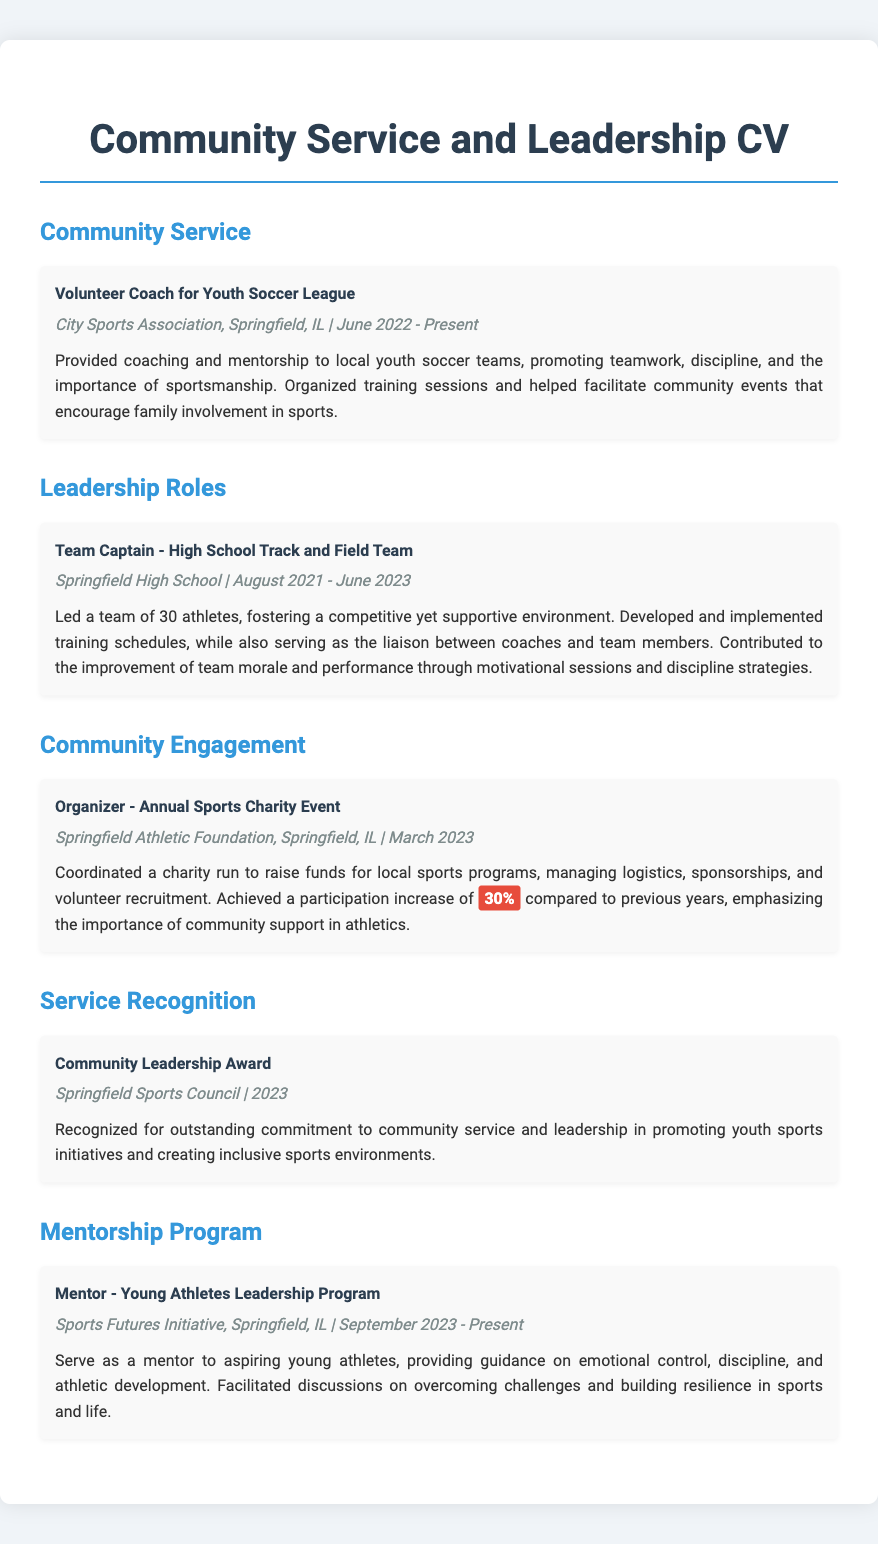What is the title of the community service role? The document specifies the community service role as "Volunteer Coach for Youth Soccer League."
Answer: Volunteer Coach for Youth Soccer League In which year did the Team Captain role begin? The role of Team Captain started in August 2021, as mentioned in the entry details.
Answer: August 2021 What organization recognized the Community Leadership Award? The Community Leadership Award was recognized by the Springfield Sports Council.
Answer: Springfield Sports Council What was the percentage increase in participation for the Annual Sports Charity Event? The document states a participation increase of 30% compared to previous years.
Answer: 30% Which program do you serve as a mentor for? The document mentions the Young Athletes Leadership Program in the mentorship section.
Answer: Young Athletes Leadership Program What was the duration of the Volunteer Coach position? The role of Volunteer Coach has been active from June 2022 to the present date, indicating continuous involvement.
Answer: June 2022 - Present What was the main focus of your mentorship in the Young Athletes Leadership Program? The focus of mentorship was on emotional control, discipline, and athletic development, as described in the entry.
Answer: Emotional control, discipline, and athletic development How many athletes were on the High School Track and Field Team? The document notes the team consisted of 30 athletes under your leadership.
Answer: 30 athletes What is the name of the charity event mentioned in the CV? The charity event coordinated is referred to as the Annual Sports Charity Event.
Answer: Annual Sports Charity Event 